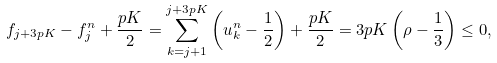<formula> <loc_0><loc_0><loc_500><loc_500>f _ { j + 3 p K } - f _ { j } ^ { n } + \frac { p K } { 2 } = \sum _ { k = j + 1 } ^ { j + 3 p K } \left ( u _ { k } ^ { n } - \frac { 1 } { 2 } \right ) + \frac { p K } { 2 } = 3 p K \left ( \rho - \frac { 1 } { 3 } \right ) \leq 0 ,</formula> 